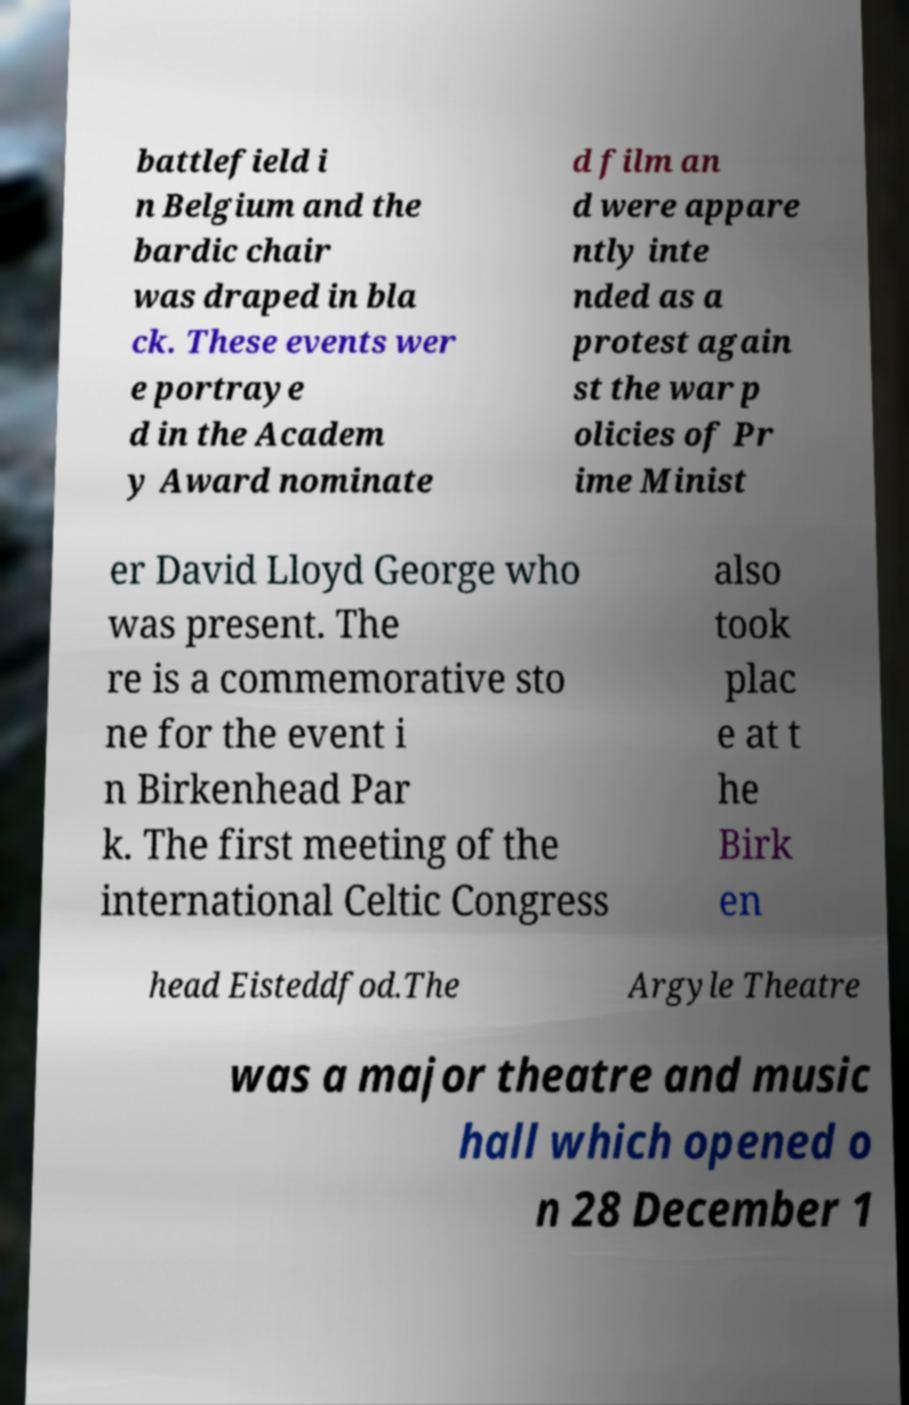Please identify and transcribe the text found in this image. battlefield i n Belgium and the bardic chair was draped in bla ck. These events wer e portraye d in the Academ y Award nominate d film an d were appare ntly inte nded as a protest again st the war p olicies of Pr ime Minist er David Lloyd George who was present. The re is a commemorative sto ne for the event i n Birkenhead Par k. The first meeting of the international Celtic Congress also took plac e at t he Birk en head Eisteddfod.The Argyle Theatre was a major theatre and music hall which opened o n 28 December 1 